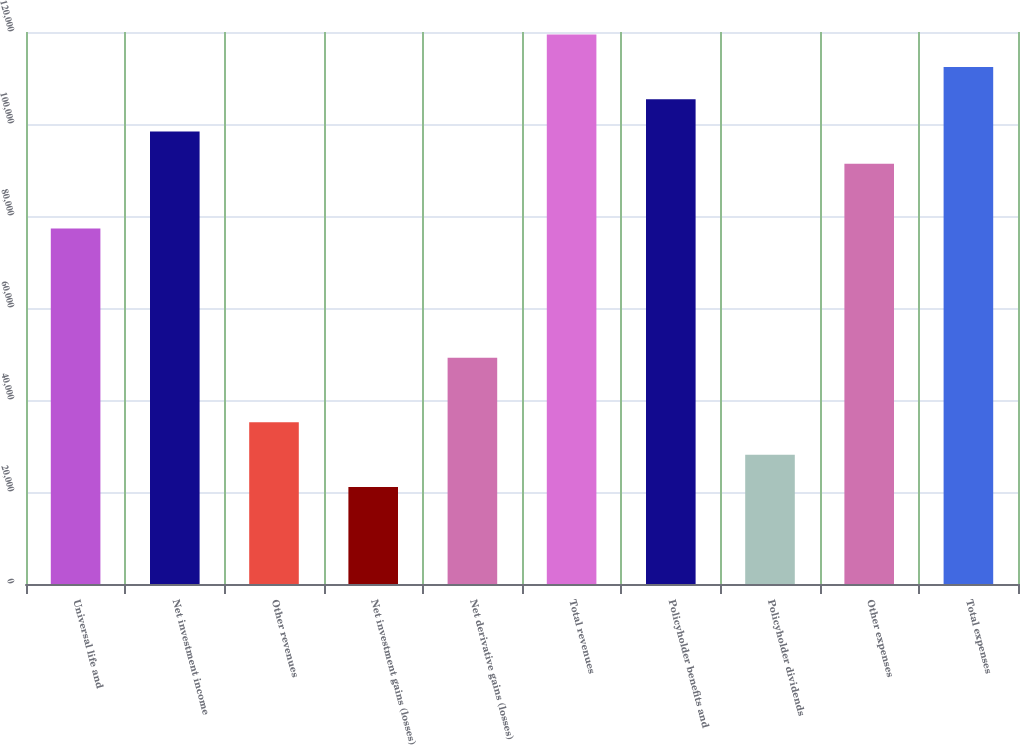Convert chart. <chart><loc_0><loc_0><loc_500><loc_500><bar_chart><fcel>Universal life and<fcel>Net investment income<fcel>Other revenues<fcel>Net investment gains (losses)<fcel>Net derivative gains (losses)<fcel>Total revenues<fcel>Policyholder benefits and<fcel>Policyholder dividends<fcel>Other expenses<fcel>Total expenses<nl><fcel>77287.2<fcel>98362.8<fcel>35136<fcel>21085.6<fcel>49186.4<fcel>119438<fcel>105388<fcel>28110.8<fcel>91337.6<fcel>112413<nl></chart> 